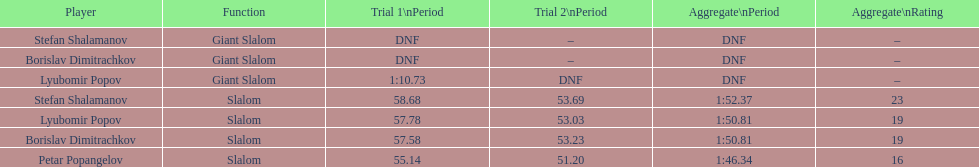What is the rank number of stefan shalamanov in the slalom event 23. 